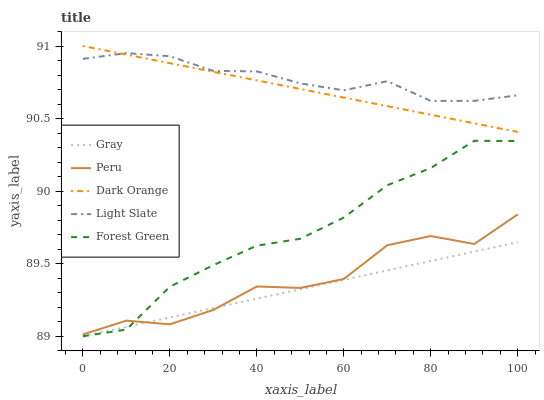Does Gray have the minimum area under the curve?
Answer yes or no. Yes. Does Light Slate have the maximum area under the curve?
Answer yes or no. Yes. Does Forest Green have the minimum area under the curve?
Answer yes or no. No. Does Forest Green have the maximum area under the curve?
Answer yes or no. No. Is Dark Orange the smoothest?
Answer yes or no. Yes. Is Peru the roughest?
Answer yes or no. Yes. Is Gray the smoothest?
Answer yes or no. No. Is Gray the roughest?
Answer yes or no. No. Does Gray have the lowest value?
Answer yes or no. Yes. Does Peru have the lowest value?
Answer yes or no. No. Does Dark Orange have the highest value?
Answer yes or no. Yes. Does Forest Green have the highest value?
Answer yes or no. No. Is Gray less than Light Slate?
Answer yes or no. Yes. Is Light Slate greater than Gray?
Answer yes or no. Yes. Does Dark Orange intersect Light Slate?
Answer yes or no. Yes. Is Dark Orange less than Light Slate?
Answer yes or no. No. Is Dark Orange greater than Light Slate?
Answer yes or no. No. Does Gray intersect Light Slate?
Answer yes or no. No. 